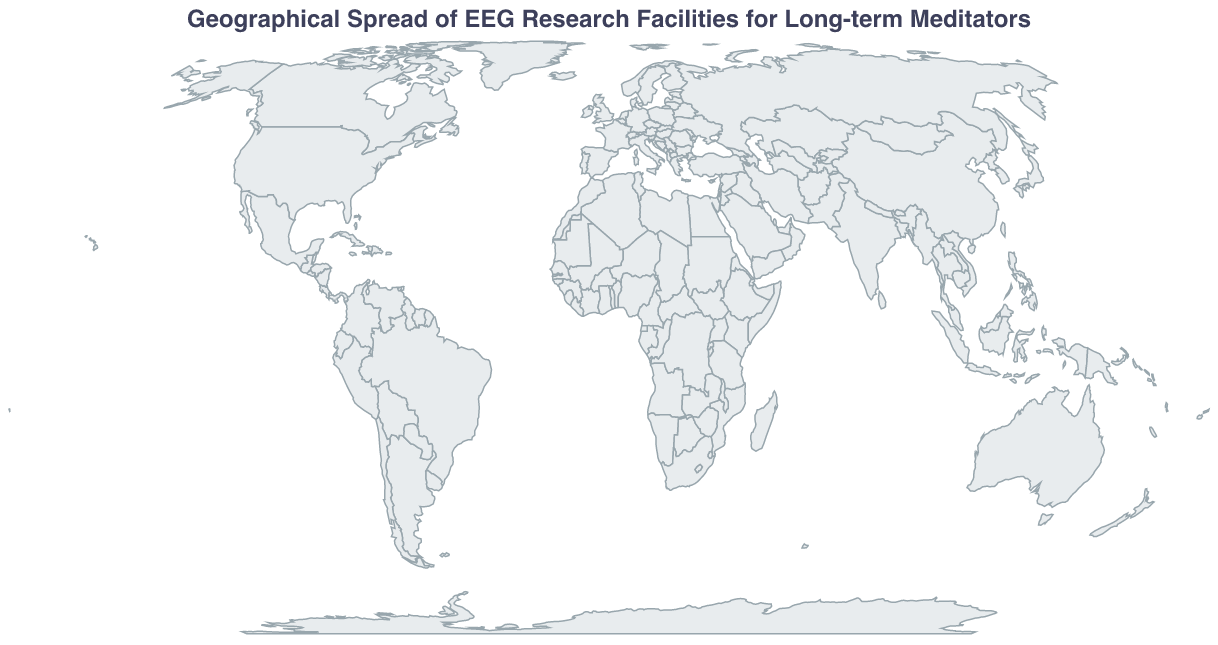What is the title of the figure? The title is presented at the top of the figure and indicates what the map represents.
Answer: Geographical Spread of EEG Research Facilities for Long-term Meditators Which research center has studied the largest number of meditators? By observing the size of the circles on the map, the largest circle corresponds to the point indicating the highest number of meditators studied.
Answer: Center for Healthy Minds - University of Wisconsin What is the country with the facility that studied the least number of meditators, and how many were studied? The smallest circle provides a visual cue of the facility with the least number of meditators studied, and the tooltip gives additional information on the research center and its location.
Answer: UK, 51 How many research facilities are located in the United States? By identifying the cities in the United States on the map and counting their corresponding circles.
Answer: 2 What is the median number of meditators studied across all research centers? To find the median, list all the numbers of meditators studied in ascending order and pick the middle one. If the count is even, average the two middle numbers: sorted values are 51, 64, 76, 79, 85, 93, 103, 112, 127, 138. The median is the average of the 5th and 6th values. (85+93)/2.
Answer: 89 Which continent has the highest concentration of research facilities? By observing the geographic distribution of research circles, the continent with the most circles will have the highest concentration.
Answer: Asia Compare the number of meditators studied in Dharamsala, India to those in Kyoto, Japan. Which city has more, and by how many? Look at the numbers of meditators studied for Dharamsala (127) and Kyoto (85). Subtract the smaller number from the larger one. 127 - 85 = 42.
Answer: Dharamsala, India by 42 How are the sizes of the circles on the map determined? Observe the legend or visual encoding in the figure; the size of the circles is often related to the quantitative variable, which is the number of meditators studied.
Answer: Based on the number of meditators studied Which research facility is located closest to the equator? The latitude closest to zero indicates proximity to the equator, which can be identified by comparing the latitudes listed in the table.
Answer: Mahidol University Contemplative Neuroscience Center in Chiang Mai, Thailand What is the total number of meditators studied across all research facilities? Add the number of meditators studied at all the listed research centers: 127 + 93 + 85 + 76 + 112 + 138 + 64 + 51 + 103 + 79.
Answer: 928 